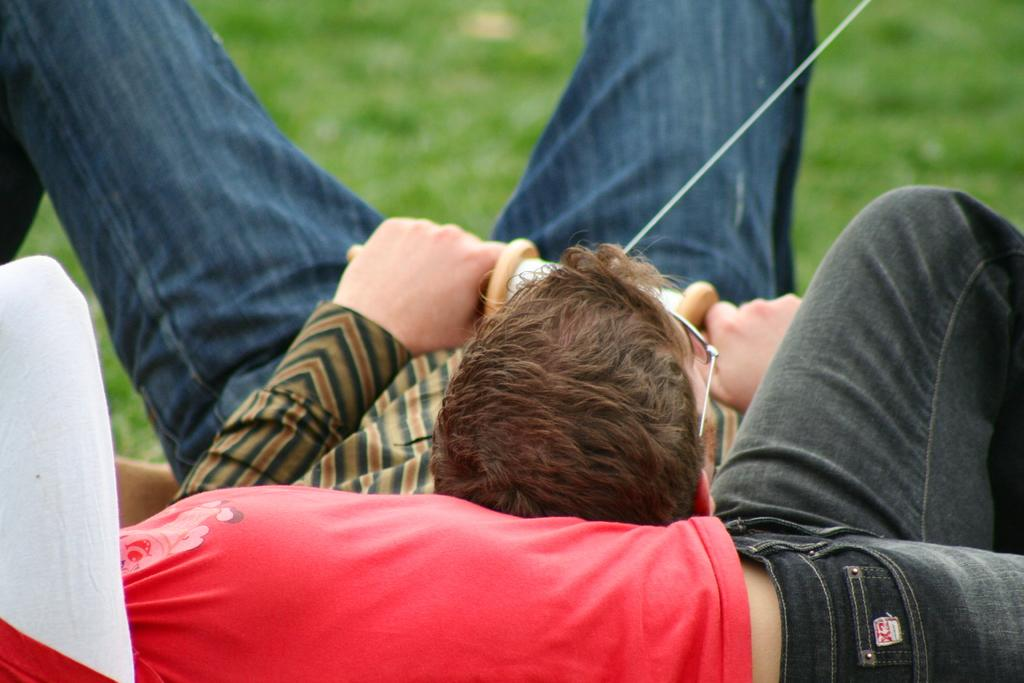What are the two people in the image doing? The two people are lying in the image. What is one person holding in the image? One person is holding a wooden object. What is the nature of the threat to the wooden object? The nature of the threat to the wooden object is not specified in the facts provided. What type of vegetation is visible at the top of the image? Grass is visible at the top of the image. How much payment is required to gain authority over the waves in the image? There are no waves present in the image, so the question of payment and authority over them is not applicable. 